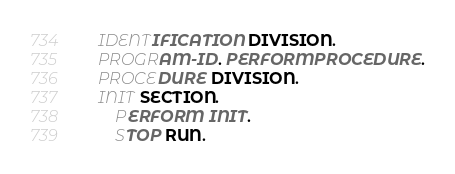<code> <loc_0><loc_0><loc_500><loc_500><_COBOL_> IDENTIFICATION DIVISION.
 PROGRAM-ID. PERFORMPROCEDURE.
 PROCEDURE DIVISION.
 INIT SECTION.
     PERFORM INIT.
     STOP RUN.</code> 